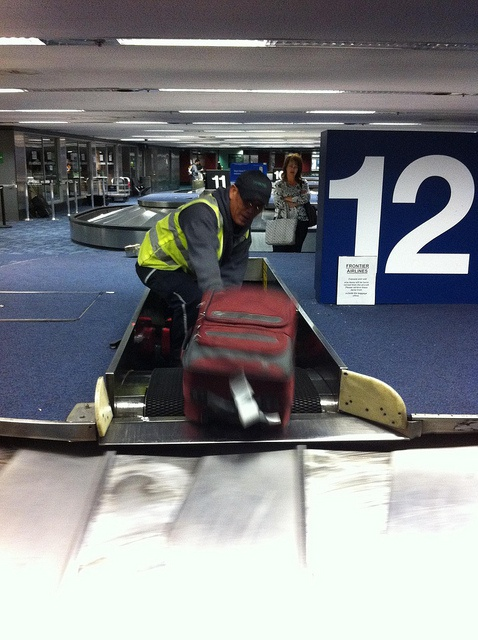Describe the objects in this image and their specific colors. I can see suitcase in gray, black, maroon, and brown tones, people in gray, black, and olive tones, people in gray, black, and maroon tones, and handbag in gray and black tones in this image. 